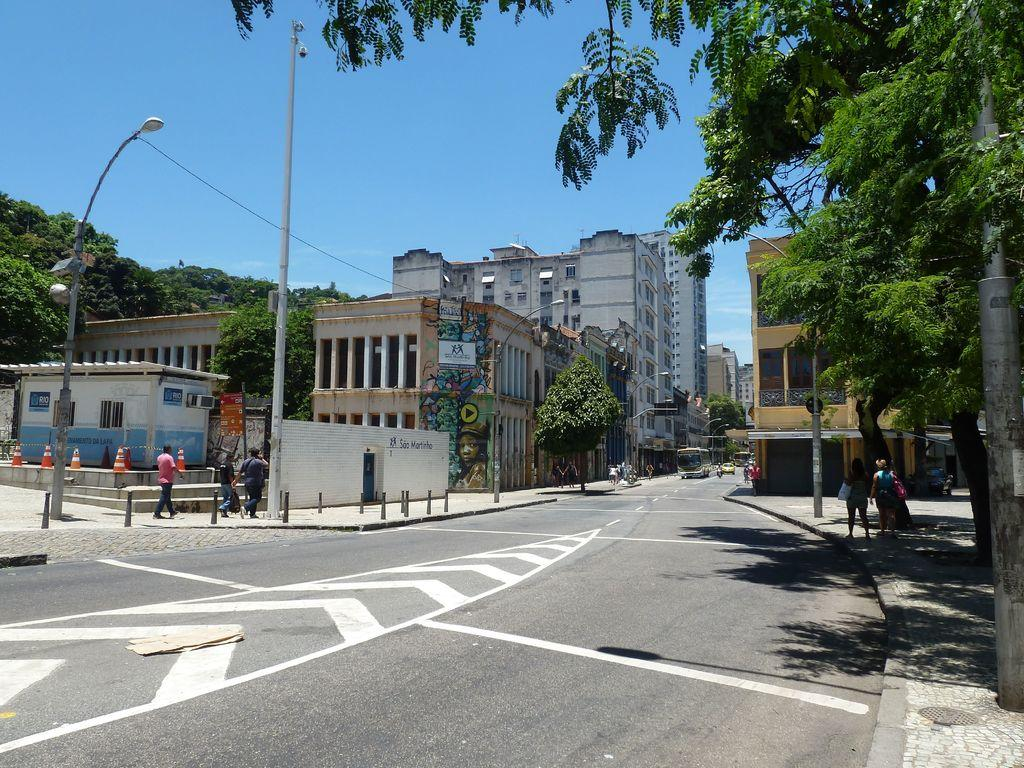What type of structures can be seen in the image? There are buildings in the image. What might provide illumination at night in the image? Street lights are present in the image. What are the vertical structures that support the street lights? Poles are visible in the image. Who or what else is present in the image? There are people and vehicles in the image. What is the setting of the image? Trees and the sky are visible in the background of the image. Can you see a duck waving its finger at the buildings in the image? There is no duck or finger-waving action present in the image. 